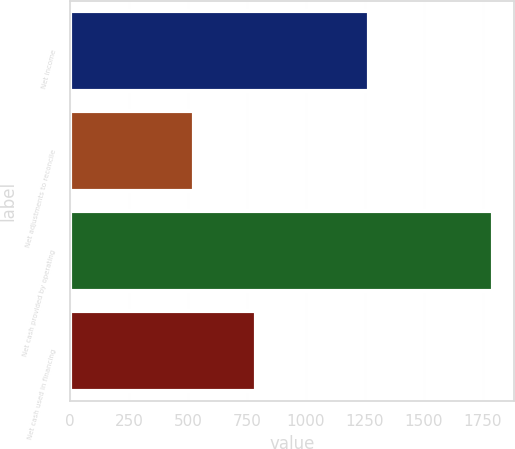<chart> <loc_0><loc_0><loc_500><loc_500><bar_chart><fcel>Net income<fcel>Net adjustments to reconcile<fcel>Net cash provided by operating<fcel>Net cash used in financing<nl><fcel>1267<fcel>525<fcel>1792<fcel>788<nl></chart> 